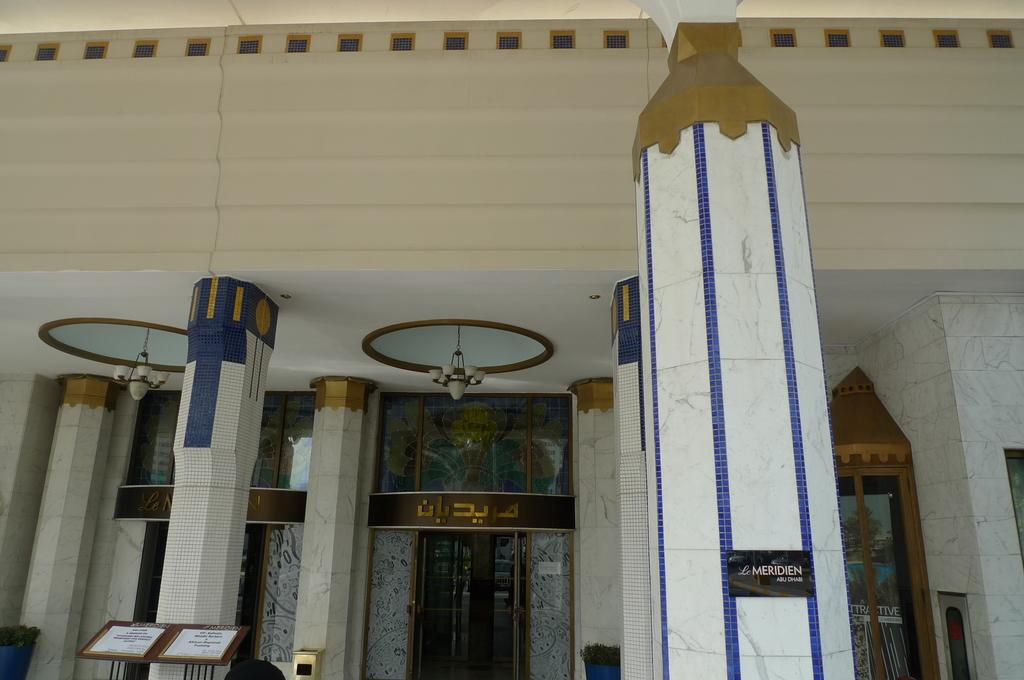What architectural features can be seen in the image? There are pillars, a door, lights, windows, and a wall in the image. Can you describe the purpose of the door in the image? The door in the image is likely used for entering or exiting a room or building. What type of illumination is present in the image? There are lights in the image, which provide artificial lighting. How can natural light enter the space in the image? There are windows in the image, which allow natural light to enter the space. What type of juice can be seen in the image? There is no juice present in the image; it only features architectural elements such as pillars, a door, lights, windows, and a wall. 